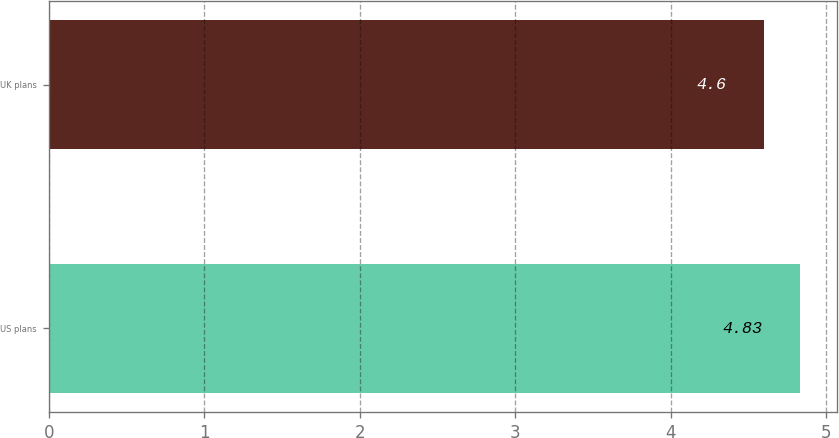<chart> <loc_0><loc_0><loc_500><loc_500><bar_chart><fcel>US plans<fcel>UK plans<nl><fcel>4.83<fcel>4.6<nl></chart> 